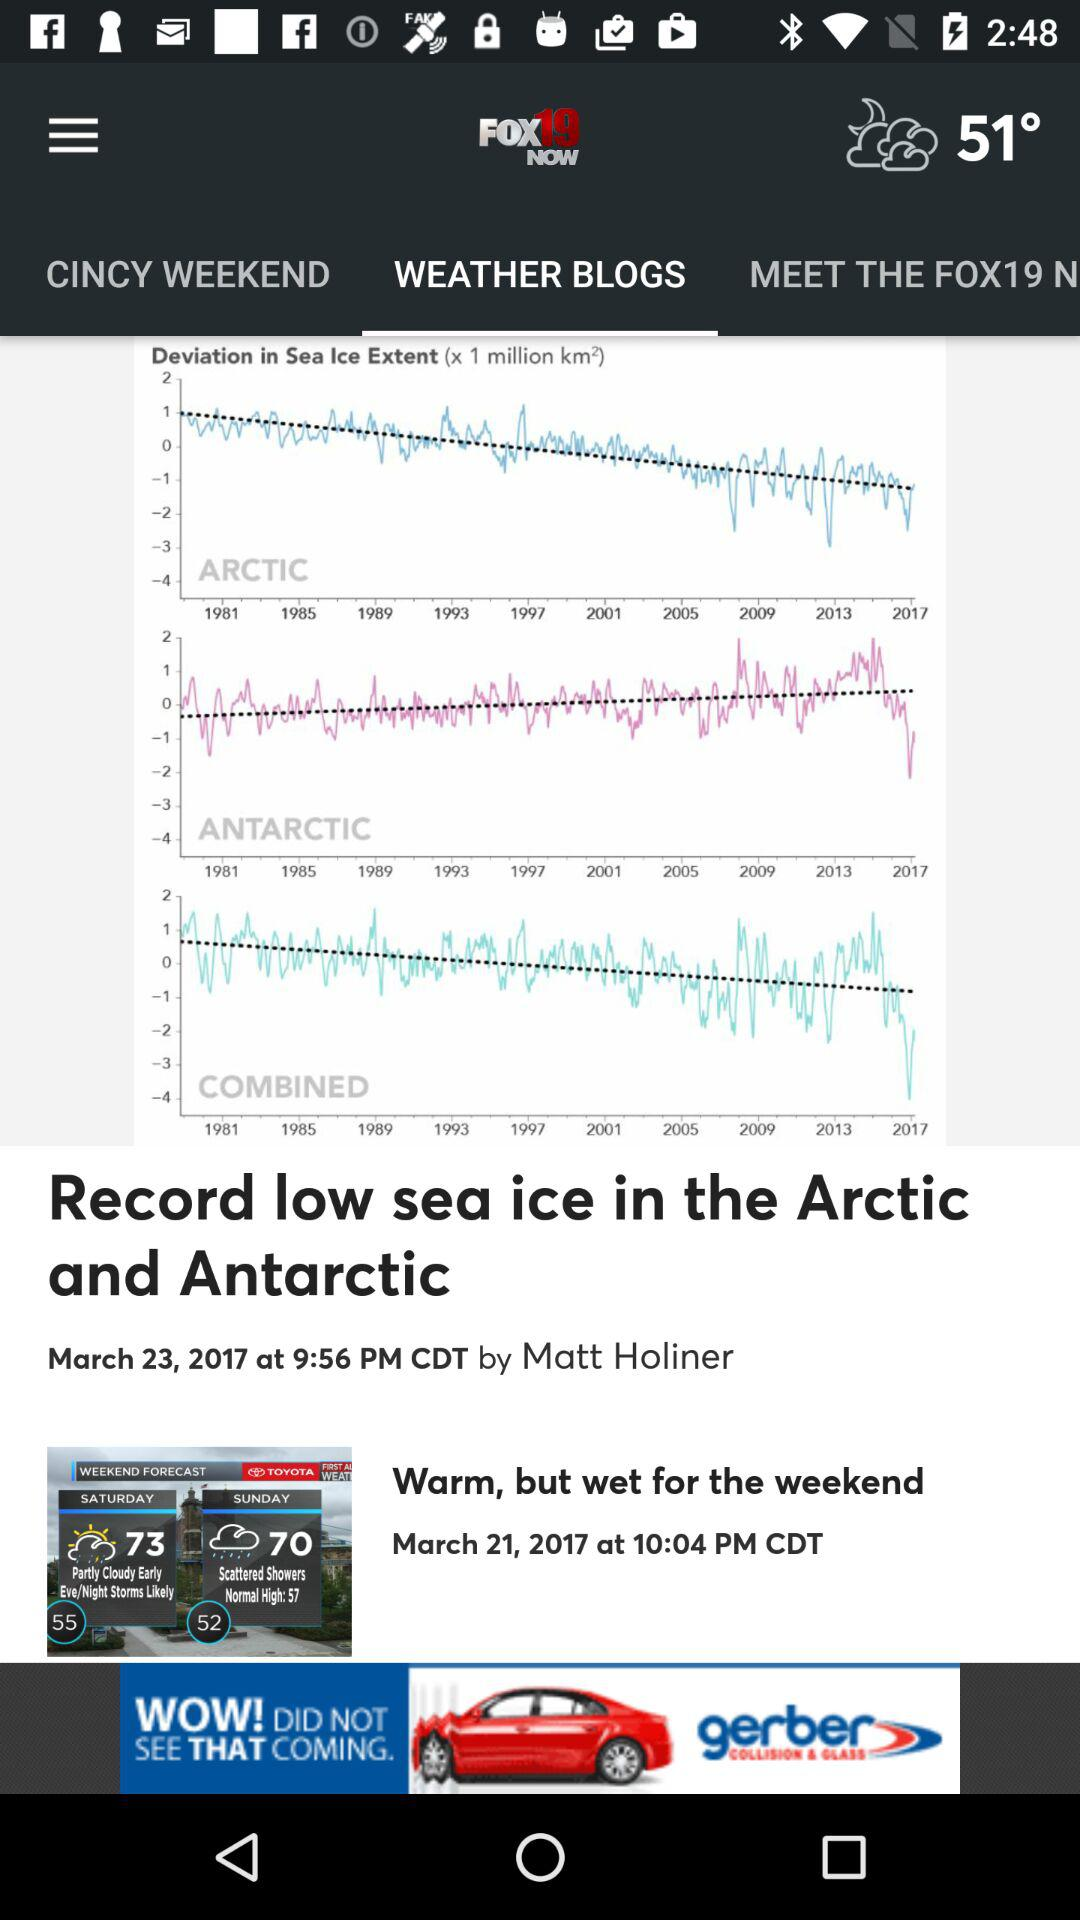Which tab is selected? The selected tab is "WEATHER BLOGS". 